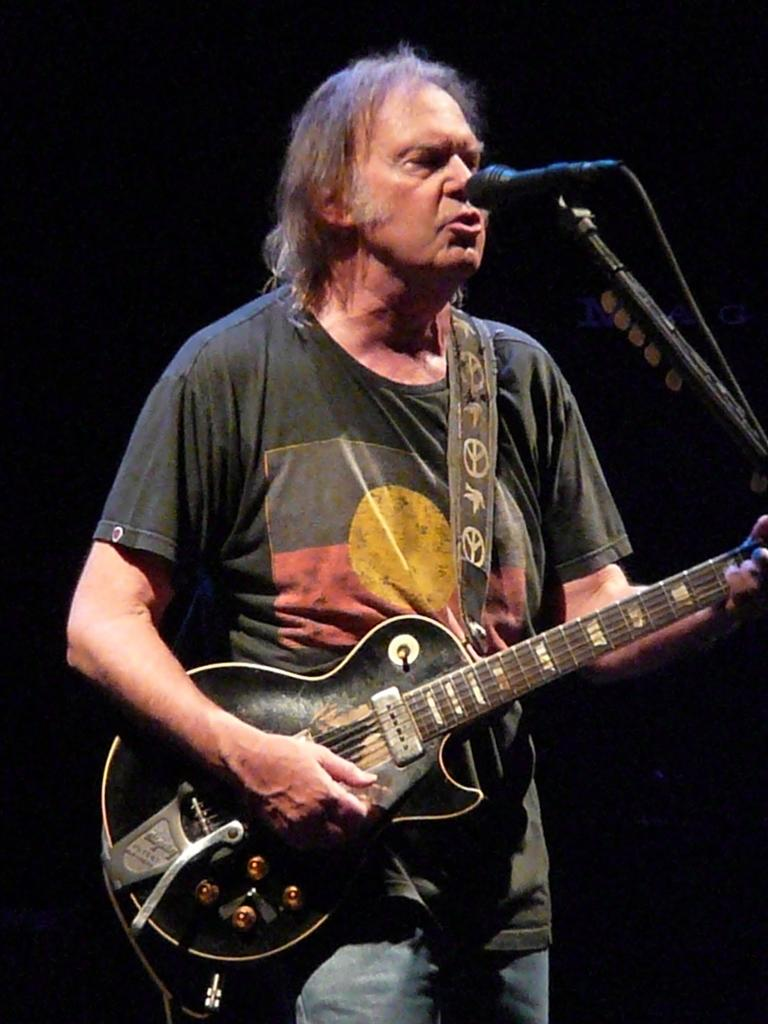Who is the main subject in the image? There is a man in the image. Where is the man positioned in the image? The man is standing in the center of the image. What is the man holding in the image? The man is holding a guitar. What object is in front of the man? There is a microphone in front of the man. What type of error can be seen in the man's mouth in the image? There is no error visible in the man's mouth in the image. 